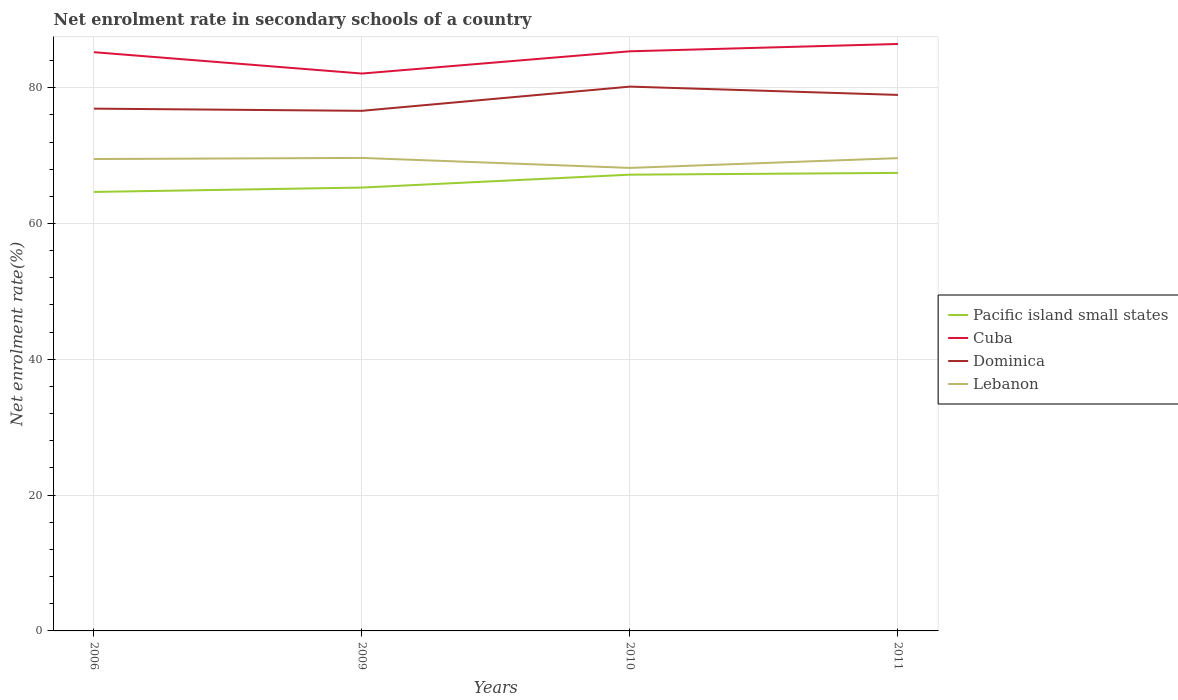How many different coloured lines are there?
Give a very brief answer. 4. Is the number of lines equal to the number of legend labels?
Offer a terse response. Yes. Across all years, what is the maximum net enrolment rate in secondary schools in Lebanon?
Keep it short and to the point. 68.18. What is the total net enrolment rate in secondary schools in Lebanon in the graph?
Offer a terse response. 1.31. What is the difference between the highest and the second highest net enrolment rate in secondary schools in Cuba?
Offer a terse response. 4.35. What is the difference between two consecutive major ticks on the Y-axis?
Ensure brevity in your answer.  20. Does the graph contain grids?
Your answer should be compact. Yes. Where does the legend appear in the graph?
Ensure brevity in your answer.  Center right. How many legend labels are there?
Your response must be concise. 4. How are the legend labels stacked?
Provide a succinct answer. Vertical. What is the title of the graph?
Provide a succinct answer. Net enrolment rate in secondary schools of a country. Does "Colombia" appear as one of the legend labels in the graph?
Offer a very short reply. No. What is the label or title of the X-axis?
Offer a terse response. Years. What is the label or title of the Y-axis?
Provide a succinct answer. Net enrolment rate(%). What is the Net enrolment rate(%) in Pacific island small states in 2006?
Make the answer very short. 64.65. What is the Net enrolment rate(%) in Cuba in 2006?
Keep it short and to the point. 85.23. What is the Net enrolment rate(%) of Dominica in 2006?
Offer a very short reply. 76.91. What is the Net enrolment rate(%) of Lebanon in 2006?
Keep it short and to the point. 69.49. What is the Net enrolment rate(%) of Pacific island small states in 2009?
Your answer should be very brief. 65.29. What is the Net enrolment rate(%) of Cuba in 2009?
Your response must be concise. 82.08. What is the Net enrolment rate(%) in Dominica in 2009?
Offer a very short reply. 76.59. What is the Net enrolment rate(%) in Lebanon in 2009?
Keep it short and to the point. 69.66. What is the Net enrolment rate(%) in Pacific island small states in 2010?
Provide a short and direct response. 67.19. What is the Net enrolment rate(%) in Cuba in 2010?
Ensure brevity in your answer.  85.36. What is the Net enrolment rate(%) in Dominica in 2010?
Your answer should be compact. 80.16. What is the Net enrolment rate(%) in Lebanon in 2010?
Keep it short and to the point. 68.18. What is the Net enrolment rate(%) in Pacific island small states in 2011?
Ensure brevity in your answer.  67.45. What is the Net enrolment rate(%) in Cuba in 2011?
Offer a very short reply. 86.44. What is the Net enrolment rate(%) in Dominica in 2011?
Give a very brief answer. 78.94. What is the Net enrolment rate(%) in Lebanon in 2011?
Ensure brevity in your answer.  69.62. Across all years, what is the maximum Net enrolment rate(%) of Pacific island small states?
Ensure brevity in your answer.  67.45. Across all years, what is the maximum Net enrolment rate(%) in Cuba?
Keep it short and to the point. 86.44. Across all years, what is the maximum Net enrolment rate(%) of Dominica?
Give a very brief answer. 80.16. Across all years, what is the maximum Net enrolment rate(%) of Lebanon?
Your answer should be compact. 69.66. Across all years, what is the minimum Net enrolment rate(%) in Pacific island small states?
Your answer should be very brief. 64.65. Across all years, what is the minimum Net enrolment rate(%) in Cuba?
Keep it short and to the point. 82.08. Across all years, what is the minimum Net enrolment rate(%) in Dominica?
Provide a short and direct response. 76.59. Across all years, what is the minimum Net enrolment rate(%) of Lebanon?
Your answer should be compact. 68.18. What is the total Net enrolment rate(%) in Pacific island small states in the graph?
Provide a succinct answer. 264.58. What is the total Net enrolment rate(%) of Cuba in the graph?
Offer a terse response. 339.11. What is the total Net enrolment rate(%) in Dominica in the graph?
Offer a terse response. 312.6. What is the total Net enrolment rate(%) of Lebanon in the graph?
Keep it short and to the point. 276.96. What is the difference between the Net enrolment rate(%) in Pacific island small states in 2006 and that in 2009?
Your answer should be very brief. -0.65. What is the difference between the Net enrolment rate(%) of Cuba in 2006 and that in 2009?
Give a very brief answer. 3.14. What is the difference between the Net enrolment rate(%) in Dominica in 2006 and that in 2009?
Your response must be concise. 0.32. What is the difference between the Net enrolment rate(%) in Lebanon in 2006 and that in 2009?
Offer a very short reply. -0.16. What is the difference between the Net enrolment rate(%) in Pacific island small states in 2006 and that in 2010?
Your answer should be very brief. -2.54. What is the difference between the Net enrolment rate(%) of Cuba in 2006 and that in 2010?
Your answer should be very brief. -0.13. What is the difference between the Net enrolment rate(%) of Dominica in 2006 and that in 2010?
Make the answer very short. -3.24. What is the difference between the Net enrolment rate(%) of Lebanon in 2006 and that in 2010?
Your response must be concise. 1.31. What is the difference between the Net enrolment rate(%) in Pacific island small states in 2006 and that in 2011?
Provide a succinct answer. -2.8. What is the difference between the Net enrolment rate(%) in Cuba in 2006 and that in 2011?
Offer a terse response. -1.21. What is the difference between the Net enrolment rate(%) in Dominica in 2006 and that in 2011?
Keep it short and to the point. -2.02. What is the difference between the Net enrolment rate(%) in Lebanon in 2006 and that in 2011?
Your answer should be very brief. -0.13. What is the difference between the Net enrolment rate(%) of Pacific island small states in 2009 and that in 2010?
Ensure brevity in your answer.  -1.9. What is the difference between the Net enrolment rate(%) in Cuba in 2009 and that in 2010?
Ensure brevity in your answer.  -3.28. What is the difference between the Net enrolment rate(%) in Dominica in 2009 and that in 2010?
Offer a terse response. -3.56. What is the difference between the Net enrolment rate(%) in Lebanon in 2009 and that in 2010?
Your answer should be compact. 1.47. What is the difference between the Net enrolment rate(%) in Pacific island small states in 2009 and that in 2011?
Offer a very short reply. -2.16. What is the difference between the Net enrolment rate(%) of Cuba in 2009 and that in 2011?
Make the answer very short. -4.35. What is the difference between the Net enrolment rate(%) of Dominica in 2009 and that in 2011?
Your response must be concise. -2.34. What is the difference between the Net enrolment rate(%) of Lebanon in 2009 and that in 2011?
Ensure brevity in your answer.  0.03. What is the difference between the Net enrolment rate(%) of Pacific island small states in 2010 and that in 2011?
Your answer should be very brief. -0.26. What is the difference between the Net enrolment rate(%) of Cuba in 2010 and that in 2011?
Your answer should be very brief. -1.08. What is the difference between the Net enrolment rate(%) in Dominica in 2010 and that in 2011?
Provide a short and direct response. 1.22. What is the difference between the Net enrolment rate(%) of Lebanon in 2010 and that in 2011?
Provide a short and direct response. -1.44. What is the difference between the Net enrolment rate(%) of Pacific island small states in 2006 and the Net enrolment rate(%) of Cuba in 2009?
Offer a very short reply. -17.44. What is the difference between the Net enrolment rate(%) in Pacific island small states in 2006 and the Net enrolment rate(%) in Dominica in 2009?
Keep it short and to the point. -11.95. What is the difference between the Net enrolment rate(%) in Pacific island small states in 2006 and the Net enrolment rate(%) in Lebanon in 2009?
Offer a very short reply. -5.01. What is the difference between the Net enrolment rate(%) in Cuba in 2006 and the Net enrolment rate(%) in Dominica in 2009?
Your answer should be very brief. 8.63. What is the difference between the Net enrolment rate(%) of Cuba in 2006 and the Net enrolment rate(%) of Lebanon in 2009?
Give a very brief answer. 15.57. What is the difference between the Net enrolment rate(%) in Dominica in 2006 and the Net enrolment rate(%) in Lebanon in 2009?
Offer a very short reply. 7.26. What is the difference between the Net enrolment rate(%) of Pacific island small states in 2006 and the Net enrolment rate(%) of Cuba in 2010?
Make the answer very short. -20.71. What is the difference between the Net enrolment rate(%) of Pacific island small states in 2006 and the Net enrolment rate(%) of Dominica in 2010?
Offer a very short reply. -15.51. What is the difference between the Net enrolment rate(%) of Pacific island small states in 2006 and the Net enrolment rate(%) of Lebanon in 2010?
Provide a short and direct response. -3.54. What is the difference between the Net enrolment rate(%) in Cuba in 2006 and the Net enrolment rate(%) in Dominica in 2010?
Provide a short and direct response. 5.07. What is the difference between the Net enrolment rate(%) in Cuba in 2006 and the Net enrolment rate(%) in Lebanon in 2010?
Provide a short and direct response. 17.04. What is the difference between the Net enrolment rate(%) in Dominica in 2006 and the Net enrolment rate(%) in Lebanon in 2010?
Your answer should be compact. 8.73. What is the difference between the Net enrolment rate(%) of Pacific island small states in 2006 and the Net enrolment rate(%) of Cuba in 2011?
Your answer should be compact. -21.79. What is the difference between the Net enrolment rate(%) in Pacific island small states in 2006 and the Net enrolment rate(%) in Dominica in 2011?
Ensure brevity in your answer.  -14.29. What is the difference between the Net enrolment rate(%) in Pacific island small states in 2006 and the Net enrolment rate(%) in Lebanon in 2011?
Offer a terse response. -4.98. What is the difference between the Net enrolment rate(%) of Cuba in 2006 and the Net enrolment rate(%) of Dominica in 2011?
Give a very brief answer. 6.29. What is the difference between the Net enrolment rate(%) in Cuba in 2006 and the Net enrolment rate(%) in Lebanon in 2011?
Your answer should be compact. 15.6. What is the difference between the Net enrolment rate(%) of Dominica in 2006 and the Net enrolment rate(%) of Lebanon in 2011?
Provide a succinct answer. 7.29. What is the difference between the Net enrolment rate(%) of Pacific island small states in 2009 and the Net enrolment rate(%) of Cuba in 2010?
Your answer should be compact. -20.07. What is the difference between the Net enrolment rate(%) in Pacific island small states in 2009 and the Net enrolment rate(%) in Dominica in 2010?
Make the answer very short. -14.87. What is the difference between the Net enrolment rate(%) of Pacific island small states in 2009 and the Net enrolment rate(%) of Lebanon in 2010?
Your answer should be compact. -2.89. What is the difference between the Net enrolment rate(%) in Cuba in 2009 and the Net enrolment rate(%) in Dominica in 2010?
Your response must be concise. 1.93. What is the difference between the Net enrolment rate(%) of Cuba in 2009 and the Net enrolment rate(%) of Lebanon in 2010?
Make the answer very short. 13.9. What is the difference between the Net enrolment rate(%) of Dominica in 2009 and the Net enrolment rate(%) of Lebanon in 2010?
Provide a short and direct response. 8.41. What is the difference between the Net enrolment rate(%) in Pacific island small states in 2009 and the Net enrolment rate(%) in Cuba in 2011?
Keep it short and to the point. -21.14. What is the difference between the Net enrolment rate(%) of Pacific island small states in 2009 and the Net enrolment rate(%) of Dominica in 2011?
Ensure brevity in your answer.  -13.64. What is the difference between the Net enrolment rate(%) in Pacific island small states in 2009 and the Net enrolment rate(%) in Lebanon in 2011?
Provide a short and direct response. -4.33. What is the difference between the Net enrolment rate(%) of Cuba in 2009 and the Net enrolment rate(%) of Dominica in 2011?
Your response must be concise. 3.15. What is the difference between the Net enrolment rate(%) of Cuba in 2009 and the Net enrolment rate(%) of Lebanon in 2011?
Offer a very short reply. 12.46. What is the difference between the Net enrolment rate(%) in Dominica in 2009 and the Net enrolment rate(%) in Lebanon in 2011?
Provide a succinct answer. 6.97. What is the difference between the Net enrolment rate(%) in Pacific island small states in 2010 and the Net enrolment rate(%) in Cuba in 2011?
Offer a terse response. -19.25. What is the difference between the Net enrolment rate(%) in Pacific island small states in 2010 and the Net enrolment rate(%) in Dominica in 2011?
Offer a terse response. -11.75. What is the difference between the Net enrolment rate(%) of Pacific island small states in 2010 and the Net enrolment rate(%) of Lebanon in 2011?
Give a very brief answer. -2.43. What is the difference between the Net enrolment rate(%) of Cuba in 2010 and the Net enrolment rate(%) of Dominica in 2011?
Provide a succinct answer. 6.42. What is the difference between the Net enrolment rate(%) in Cuba in 2010 and the Net enrolment rate(%) in Lebanon in 2011?
Your response must be concise. 15.74. What is the difference between the Net enrolment rate(%) in Dominica in 2010 and the Net enrolment rate(%) in Lebanon in 2011?
Provide a succinct answer. 10.53. What is the average Net enrolment rate(%) in Pacific island small states per year?
Give a very brief answer. 66.14. What is the average Net enrolment rate(%) of Cuba per year?
Provide a short and direct response. 84.78. What is the average Net enrolment rate(%) of Dominica per year?
Offer a very short reply. 78.15. What is the average Net enrolment rate(%) of Lebanon per year?
Provide a short and direct response. 69.24. In the year 2006, what is the difference between the Net enrolment rate(%) in Pacific island small states and Net enrolment rate(%) in Cuba?
Make the answer very short. -20.58. In the year 2006, what is the difference between the Net enrolment rate(%) of Pacific island small states and Net enrolment rate(%) of Dominica?
Provide a short and direct response. -12.27. In the year 2006, what is the difference between the Net enrolment rate(%) of Pacific island small states and Net enrolment rate(%) of Lebanon?
Offer a terse response. -4.85. In the year 2006, what is the difference between the Net enrolment rate(%) of Cuba and Net enrolment rate(%) of Dominica?
Provide a short and direct response. 8.31. In the year 2006, what is the difference between the Net enrolment rate(%) in Cuba and Net enrolment rate(%) in Lebanon?
Ensure brevity in your answer.  15.73. In the year 2006, what is the difference between the Net enrolment rate(%) in Dominica and Net enrolment rate(%) in Lebanon?
Your answer should be very brief. 7.42. In the year 2009, what is the difference between the Net enrolment rate(%) of Pacific island small states and Net enrolment rate(%) of Cuba?
Your answer should be compact. -16.79. In the year 2009, what is the difference between the Net enrolment rate(%) of Pacific island small states and Net enrolment rate(%) of Dominica?
Offer a terse response. -11.3. In the year 2009, what is the difference between the Net enrolment rate(%) in Pacific island small states and Net enrolment rate(%) in Lebanon?
Your response must be concise. -4.36. In the year 2009, what is the difference between the Net enrolment rate(%) in Cuba and Net enrolment rate(%) in Dominica?
Offer a terse response. 5.49. In the year 2009, what is the difference between the Net enrolment rate(%) in Cuba and Net enrolment rate(%) in Lebanon?
Provide a succinct answer. 12.43. In the year 2009, what is the difference between the Net enrolment rate(%) in Dominica and Net enrolment rate(%) in Lebanon?
Give a very brief answer. 6.94. In the year 2010, what is the difference between the Net enrolment rate(%) in Pacific island small states and Net enrolment rate(%) in Cuba?
Your answer should be very brief. -18.17. In the year 2010, what is the difference between the Net enrolment rate(%) of Pacific island small states and Net enrolment rate(%) of Dominica?
Your answer should be compact. -12.97. In the year 2010, what is the difference between the Net enrolment rate(%) of Pacific island small states and Net enrolment rate(%) of Lebanon?
Your response must be concise. -0.99. In the year 2010, what is the difference between the Net enrolment rate(%) of Cuba and Net enrolment rate(%) of Dominica?
Your answer should be compact. 5.2. In the year 2010, what is the difference between the Net enrolment rate(%) of Cuba and Net enrolment rate(%) of Lebanon?
Offer a very short reply. 17.17. In the year 2010, what is the difference between the Net enrolment rate(%) in Dominica and Net enrolment rate(%) in Lebanon?
Make the answer very short. 11.97. In the year 2011, what is the difference between the Net enrolment rate(%) of Pacific island small states and Net enrolment rate(%) of Cuba?
Make the answer very short. -18.99. In the year 2011, what is the difference between the Net enrolment rate(%) in Pacific island small states and Net enrolment rate(%) in Dominica?
Offer a very short reply. -11.49. In the year 2011, what is the difference between the Net enrolment rate(%) of Pacific island small states and Net enrolment rate(%) of Lebanon?
Your response must be concise. -2.17. In the year 2011, what is the difference between the Net enrolment rate(%) of Cuba and Net enrolment rate(%) of Dominica?
Give a very brief answer. 7.5. In the year 2011, what is the difference between the Net enrolment rate(%) in Cuba and Net enrolment rate(%) in Lebanon?
Your response must be concise. 16.81. In the year 2011, what is the difference between the Net enrolment rate(%) of Dominica and Net enrolment rate(%) of Lebanon?
Provide a short and direct response. 9.31. What is the ratio of the Net enrolment rate(%) in Cuba in 2006 to that in 2009?
Ensure brevity in your answer.  1.04. What is the ratio of the Net enrolment rate(%) in Dominica in 2006 to that in 2009?
Provide a succinct answer. 1. What is the ratio of the Net enrolment rate(%) of Pacific island small states in 2006 to that in 2010?
Offer a terse response. 0.96. What is the ratio of the Net enrolment rate(%) of Cuba in 2006 to that in 2010?
Provide a succinct answer. 1. What is the ratio of the Net enrolment rate(%) in Dominica in 2006 to that in 2010?
Your answer should be very brief. 0.96. What is the ratio of the Net enrolment rate(%) in Lebanon in 2006 to that in 2010?
Offer a terse response. 1.02. What is the ratio of the Net enrolment rate(%) of Pacific island small states in 2006 to that in 2011?
Give a very brief answer. 0.96. What is the ratio of the Net enrolment rate(%) of Dominica in 2006 to that in 2011?
Your answer should be very brief. 0.97. What is the ratio of the Net enrolment rate(%) in Lebanon in 2006 to that in 2011?
Your answer should be compact. 1. What is the ratio of the Net enrolment rate(%) of Pacific island small states in 2009 to that in 2010?
Offer a terse response. 0.97. What is the ratio of the Net enrolment rate(%) of Cuba in 2009 to that in 2010?
Keep it short and to the point. 0.96. What is the ratio of the Net enrolment rate(%) of Dominica in 2009 to that in 2010?
Offer a very short reply. 0.96. What is the ratio of the Net enrolment rate(%) in Lebanon in 2009 to that in 2010?
Provide a short and direct response. 1.02. What is the ratio of the Net enrolment rate(%) in Cuba in 2009 to that in 2011?
Provide a short and direct response. 0.95. What is the ratio of the Net enrolment rate(%) in Dominica in 2009 to that in 2011?
Your response must be concise. 0.97. What is the ratio of the Net enrolment rate(%) of Cuba in 2010 to that in 2011?
Keep it short and to the point. 0.99. What is the ratio of the Net enrolment rate(%) in Dominica in 2010 to that in 2011?
Offer a terse response. 1.02. What is the ratio of the Net enrolment rate(%) of Lebanon in 2010 to that in 2011?
Keep it short and to the point. 0.98. What is the difference between the highest and the second highest Net enrolment rate(%) in Pacific island small states?
Provide a short and direct response. 0.26. What is the difference between the highest and the second highest Net enrolment rate(%) of Cuba?
Provide a succinct answer. 1.08. What is the difference between the highest and the second highest Net enrolment rate(%) in Dominica?
Make the answer very short. 1.22. What is the difference between the highest and the second highest Net enrolment rate(%) of Lebanon?
Your response must be concise. 0.03. What is the difference between the highest and the lowest Net enrolment rate(%) in Pacific island small states?
Keep it short and to the point. 2.8. What is the difference between the highest and the lowest Net enrolment rate(%) of Cuba?
Keep it short and to the point. 4.35. What is the difference between the highest and the lowest Net enrolment rate(%) of Dominica?
Provide a short and direct response. 3.56. What is the difference between the highest and the lowest Net enrolment rate(%) of Lebanon?
Your answer should be compact. 1.47. 